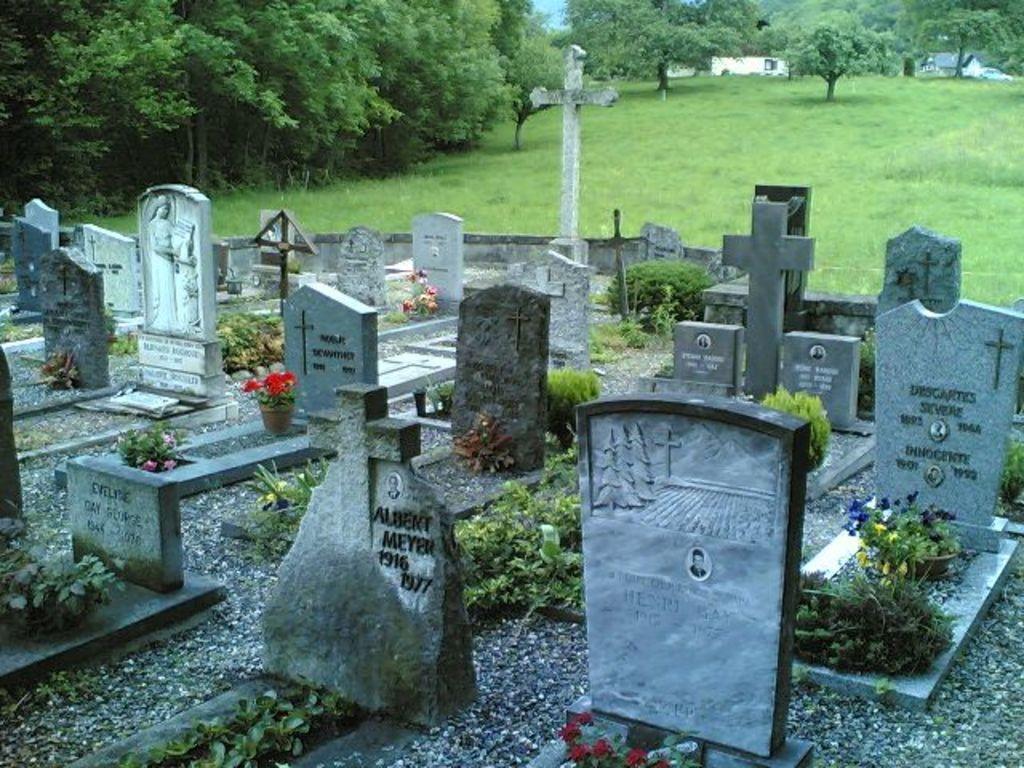Please provide a concise description of this image. In this picture I can see graveyard in the foreground. I can see grass ground. I can see group of trees in the top left-hand corner. 